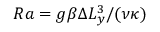<formula> <loc_0><loc_0><loc_500><loc_500>R a = g \beta \Delta L _ { y } ^ { 3 } / ( \nu \kappa )</formula> 